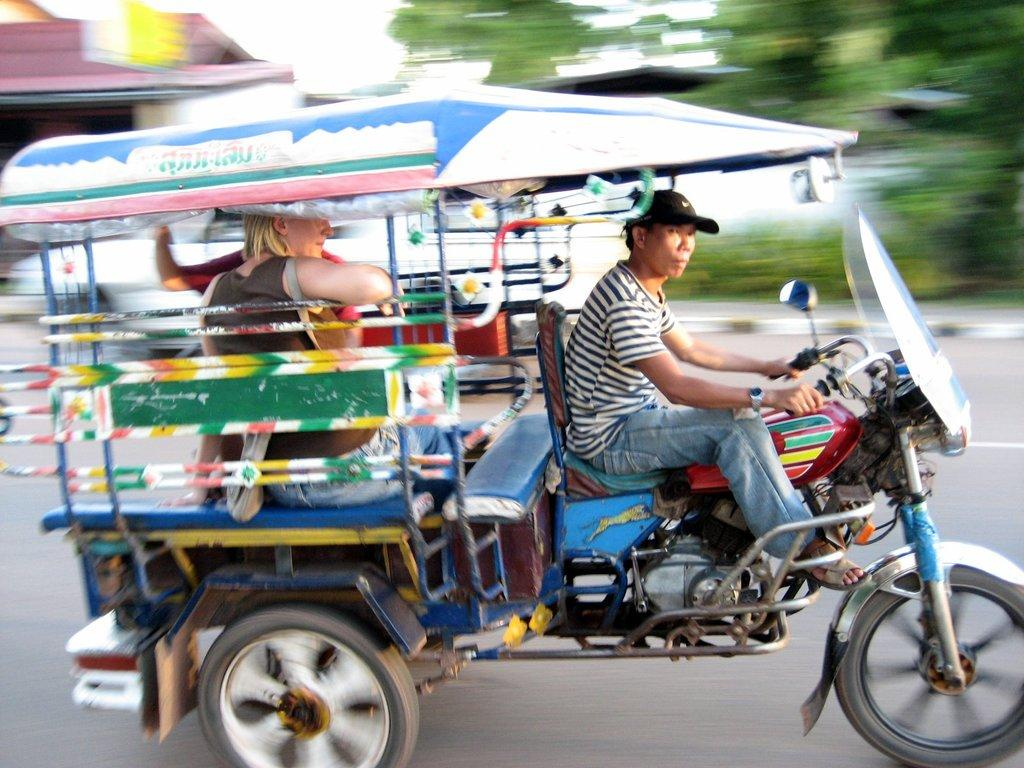What is the person in the image doing? There is a person riding a vehicle in the image. How many people are in the vehicle? There are two persons sitting in the vehicle. What can be seen in the background of the image? There is a house and trees in the background of the image. How would you describe the background in the image? The background appears blurry. What type of egg is being used as a calculator in the image? There is no egg or calculator present in the image. 